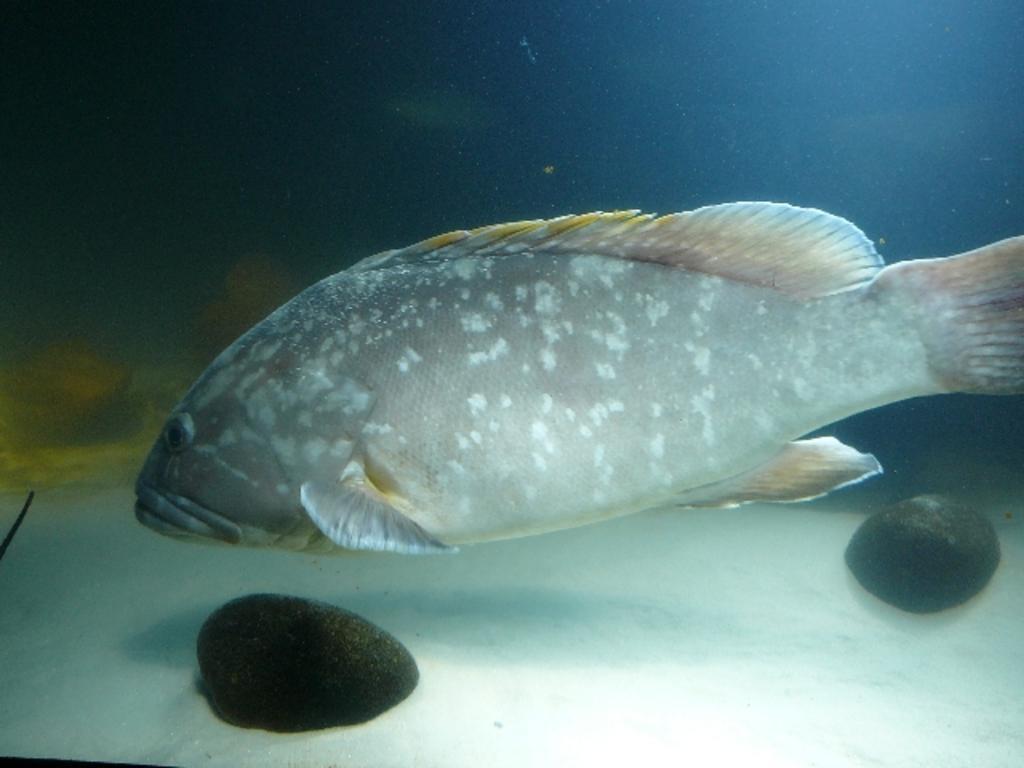Describe this image in one or two sentences. This is fish in the water, these are stones. 